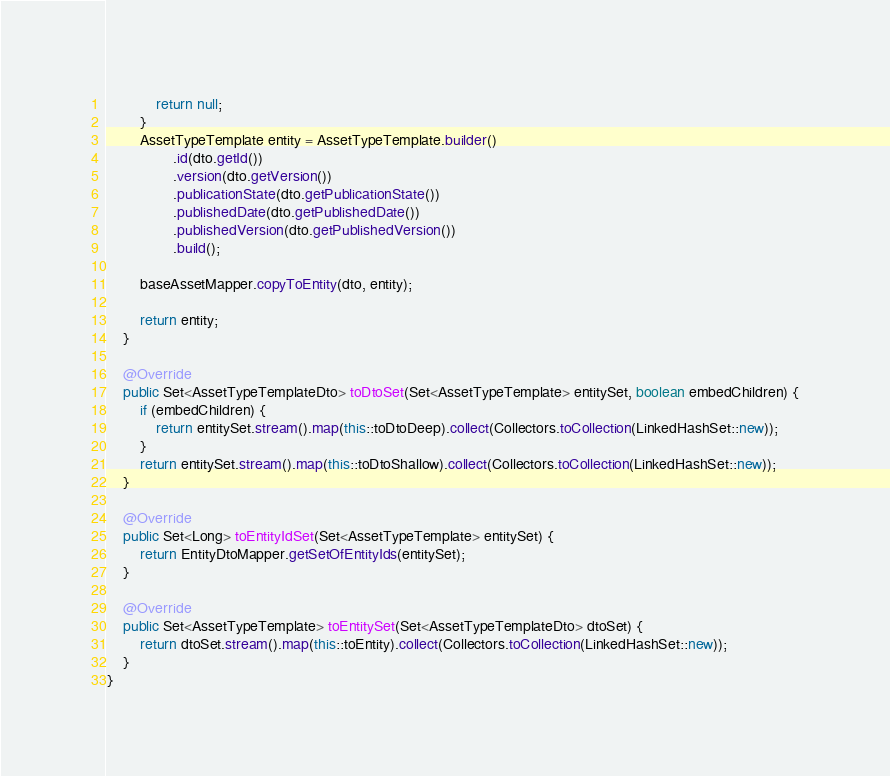Convert code to text. <code><loc_0><loc_0><loc_500><loc_500><_Java_>            return null;
        }
        AssetTypeTemplate entity = AssetTypeTemplate.builder()
                .id(dto.getId())
                .version(dto.getVersion())
                .publicationState(dto.getPublicationState())
                .publishedDate(dto.getPublishedDate())
                .publishedVersion(dto.getPublishedVersion())
                .build();

        baseAssetMapper.copyToEntity(dto, entity);

        return entity;
    }

    @Override
    public Set<AssetTypeTemplateDto> toDtoSet(Set<AssetTypeTemplate> entitySet, boolean embedChildren) {
        if (embedChildren) {
            return entitySet.stream().map(this::toDtoDeep).collect(Collectors.toCollection(LinkedHashSet::new));
        }
        return entitySet.stream().map(this::toDtoShallow).collect(Collectors.toCollection(LinkedHashSet::new));
    }

    @Override
    public Set<Long> toEntityIdSet(Set<AssetTypeTemplate> entitySet) {
        return EntityDtoMapper.getSetOfEntityIds(entitySet);
    }

    @Override
    public Set<AssetTypeTemplate> toEntitySet(Set<AssetTypeTemplateDto> dtoSet) {
        return dtoSet.stream().map(this::toEntity).collect(Collectors.toCollection(LinkedHashSet::new));
    }
}
</code> 